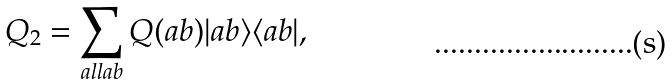Convert formula to latex. <formula><loc_0><loc_0><loc_500><loc_500>Q _ { 2 } = \sum _ { a l l a b } Q ( a b ) | a b \rangle \langle a b | ,</formula> 